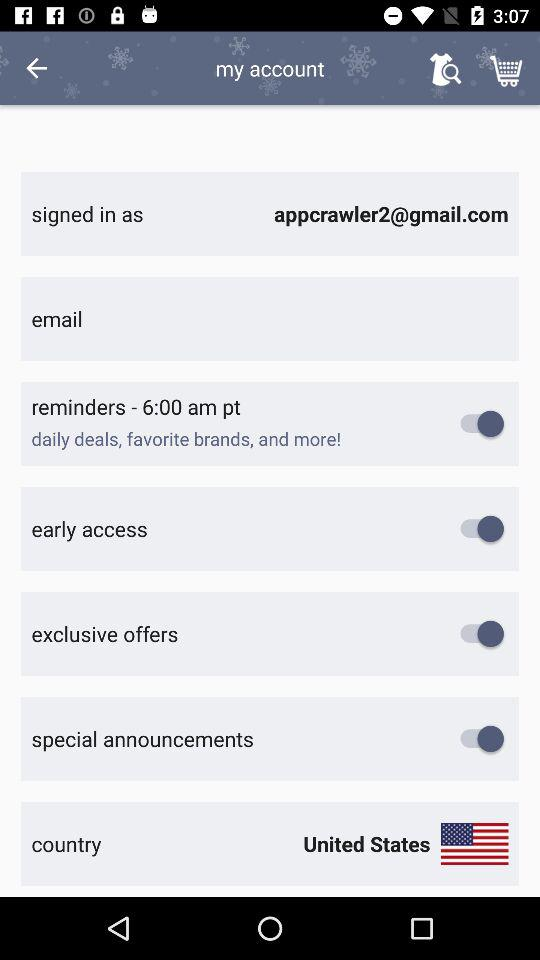What's the set reminder time? The set reminder time is 6 AM. 